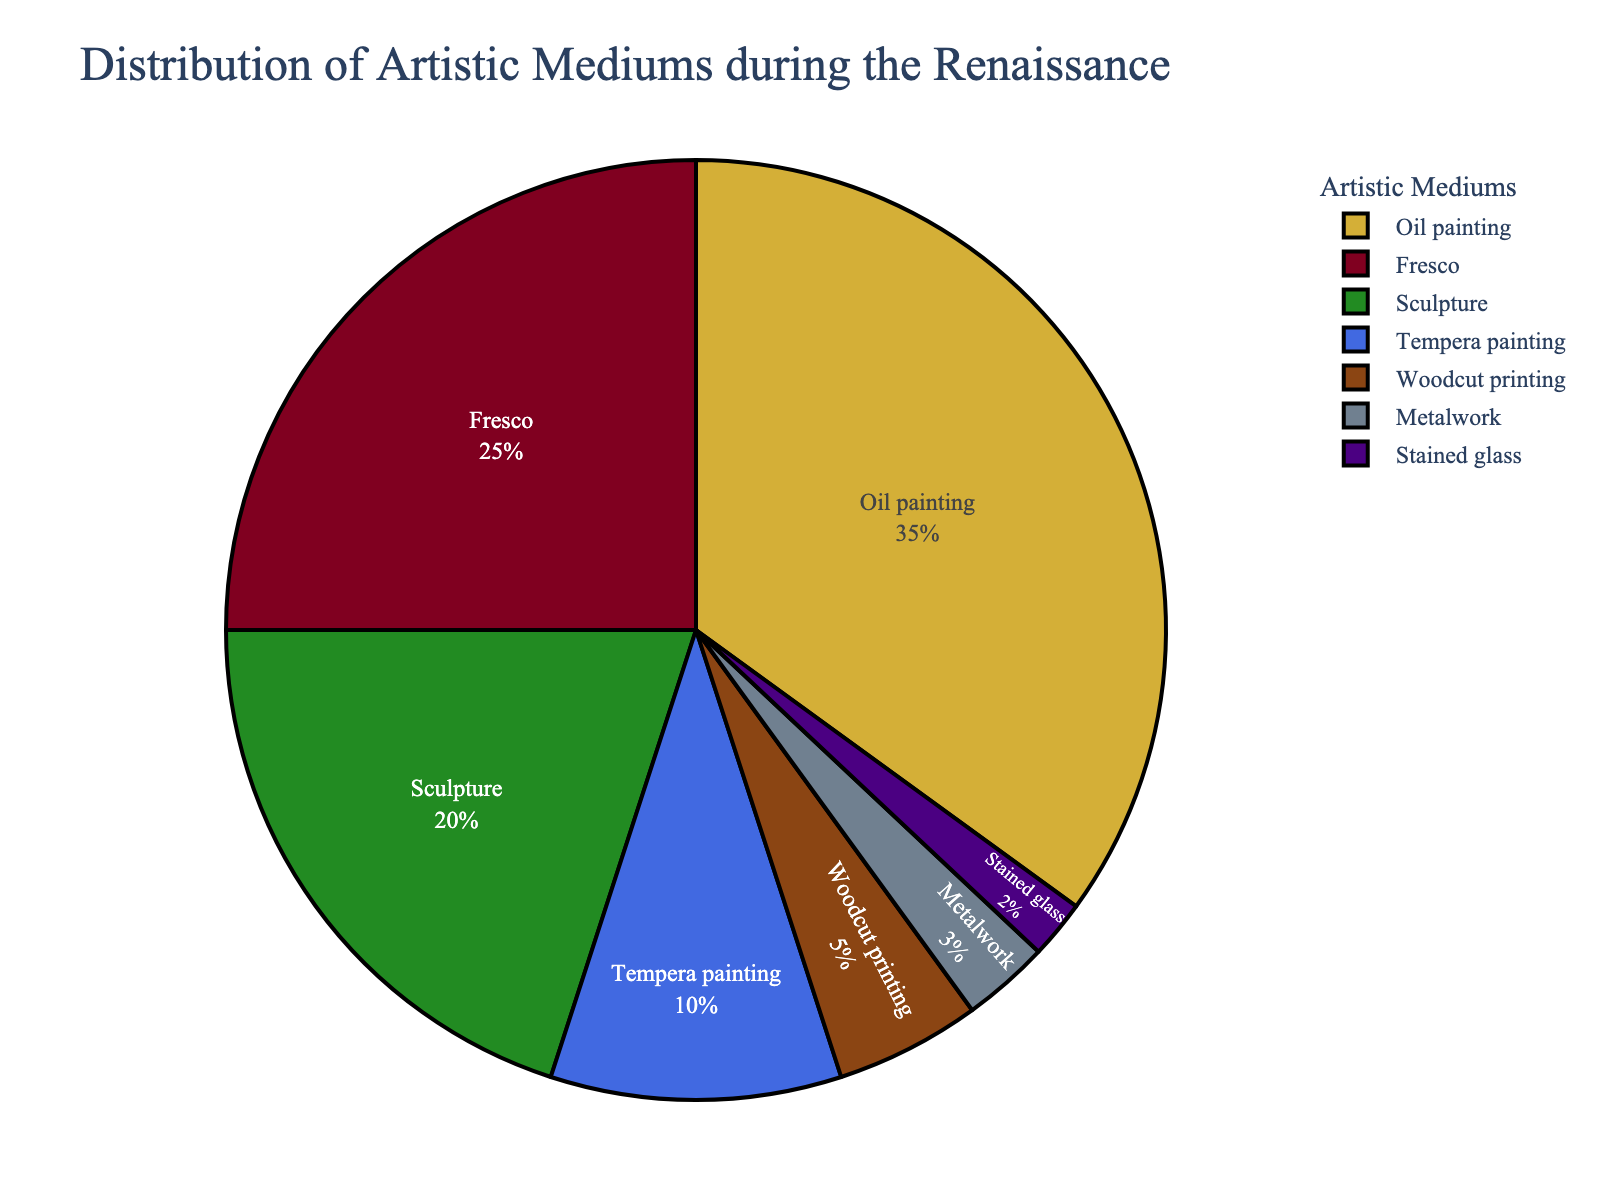What percentage of the artistic mediums during the Renaissance is accounted for by sculpture and metalwork combined? Add the percentages for sculpture (20) and metalwork (3). Therefore, 20 + 3 = 23%.
Answer: 23% Which medium has the second-highest usage percentage during the Renaissance? The pie chart shows that the second-largest section represents fresco at 25%.
Answer: Fresco How much more prevalent is oil painting compared to woodcut printing? Subtract the percentage for woodcut printing (5) from the percentage for oil painting (35). Therefore, 35 - 5 = 30%.
Answer: 30% What is the least used artistic medium during the Renaissance? The smallest section in the pie chart represents stained glass with 2%.
Answer: Stained glass What percentage of mediums are used other than oil painting? Subtract the percentage of oil painting (35) from 100. Therefore, 100 - 35 = 65%.
Answer: 65% Out of the total percentage of mediums, how many are dedicated to both tempera painting and woodcut printing combined? Sum the percentage of tempera painting (10) and woodcut printing (5). Therefore, 10 + 5 = 15%.
Answer: 15% Which section of the pie chart is represented by a golden color? The color corresponding to oil painting in the pie chart is golden.
Answer: Oil painting Is fresco usage more than twice the usage of metalwork during the Renaissance? Compare 2 times the percentage of metalwork (3 * 2 = 6) with fresco (25). Since 25 > 6, fresco usage is more than twice metalwork.
Answer: Yes Which category accounts for twice the percentage of stained glass? Stained glass accounts for 2%, so twice that is 4%. The closest percentage is woodcut printing with 5%.
Answer: Woodcut printing What is the difference in percentage usage between fresco and tempera painting? Subtract the percentage of tempera painting (10) from fresco (25). Therefore, 25 - 10 = 15%.
Answer: 15% 